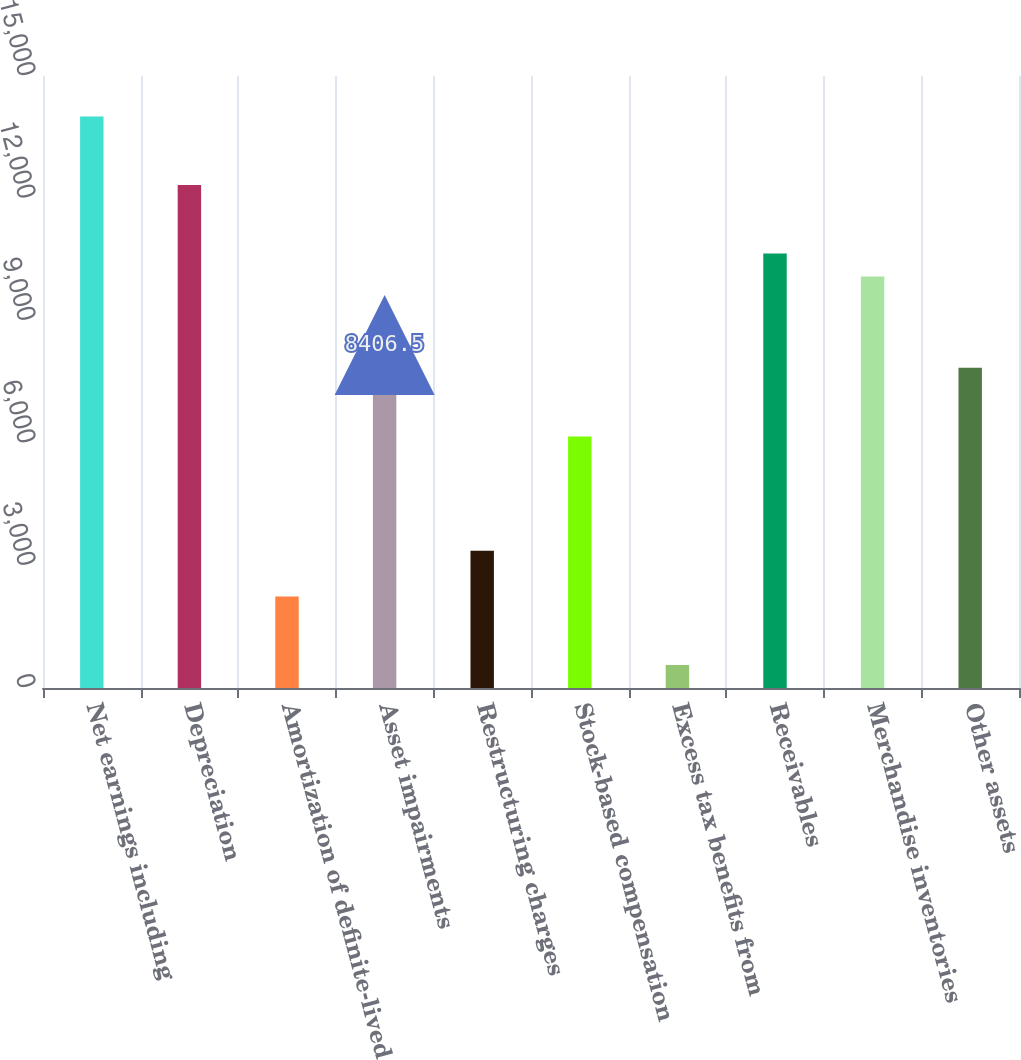Convert chart to OTSL. <chart><loc_0><loc_0><loc_500><loc_500><bar_chart><fcel>Net earnings including<fcel>Depreciation<fcel>Amortization of definite-lived<fcel>Asset impairments<fcel>Restructuring charges<fcel>Stock-based compensation<fcel>Excess tax benefits from<fcel>Receivables<fcel>Merchandise inventories<fcel>Other assets<nl><fcel>14007.5<fcel>12327.2<fcel>2245.4<fcel>8406.5<fcel>3365.6<fcel>6166.1<fcel>565.1<fcel>10646.9<fcel>10086.8<fcel>7846.4<nl></chart> 